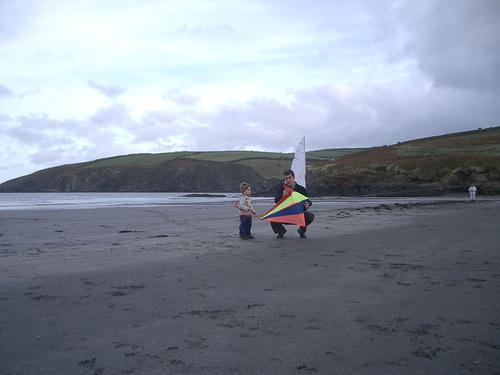How many people are there?
Give a very brief answer. 2. 